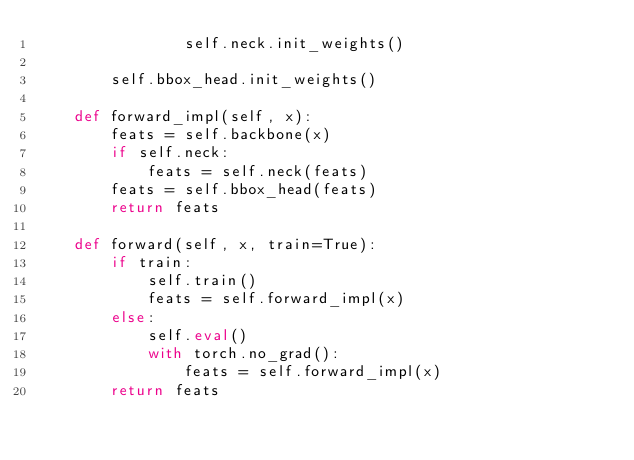Convert code to text. <code><loc_0><loc_0><loc_500><loc_500><_Python_>                self.neck.init_weights()

        self.bbox_head.init_weights()

    def forward_impl(self, x):
        feats = self.backbone(x)
        if self.neck:
            feats = self.neck(feats)
        feats = self.bbox_head(feats)
        return feats

    def forward(self, x, train=True):
        if train:
            self.train()
            feats = self.forward_impl(x)
        else:
            self.eval()
            with torch.no_grad():
                feats = self.forward_impl(x)
        return feats
</code> 